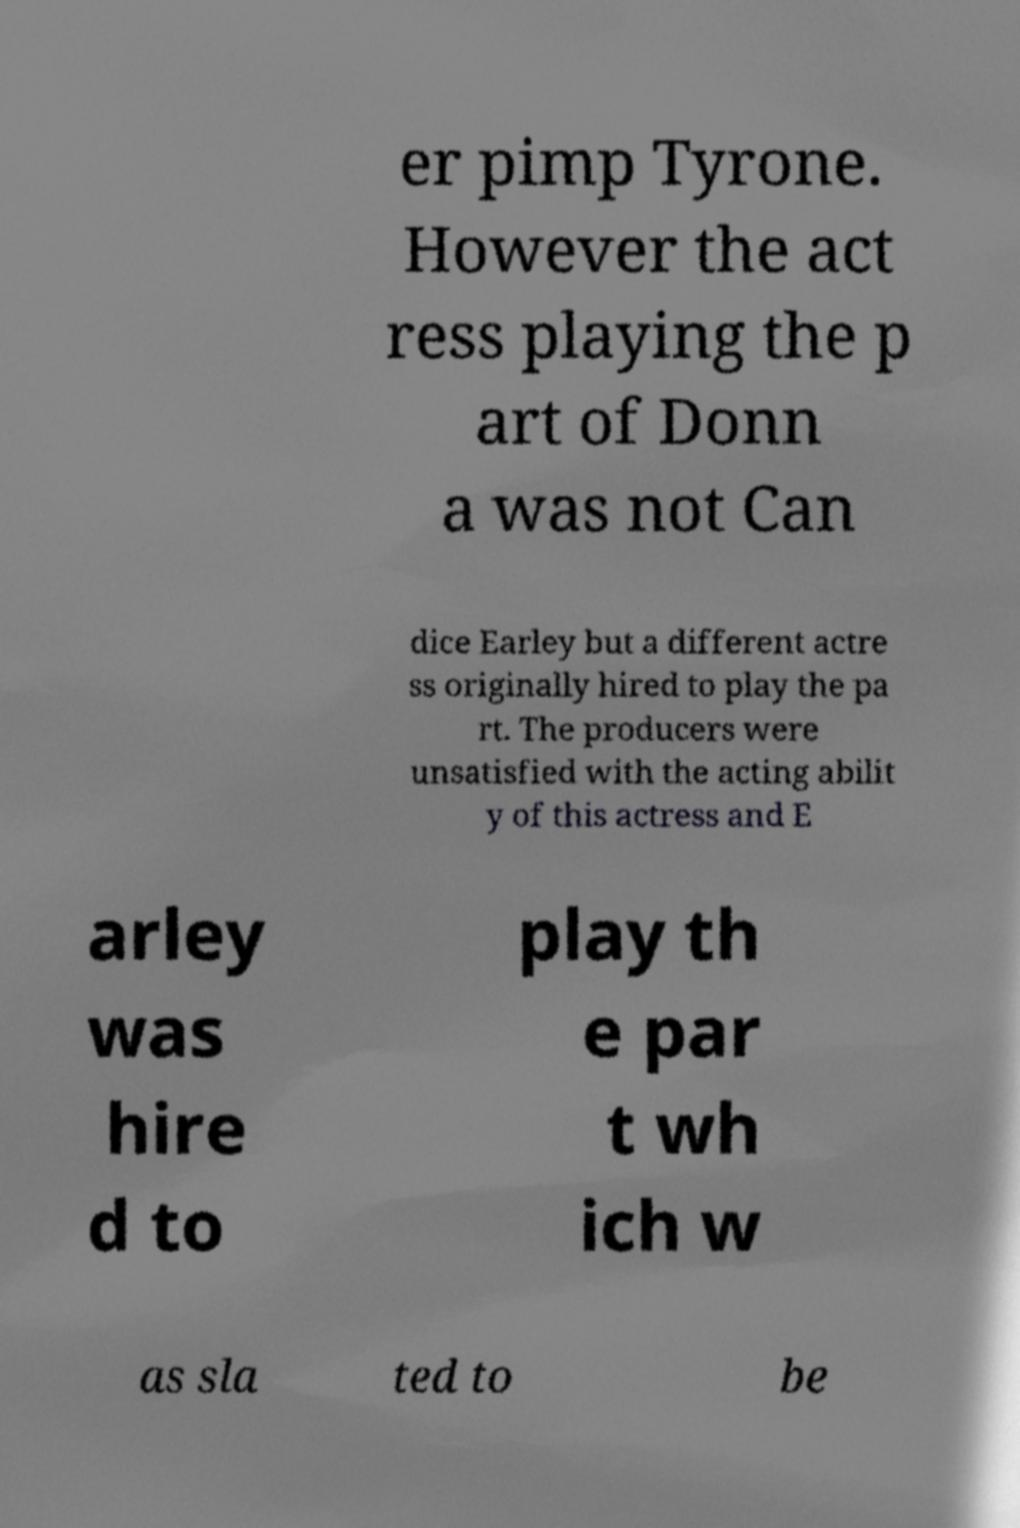There's text embedded in this image that I need extracted. Can you transcribe it verbatim? er pimp Tyrone. However the act ress playing the p art of Donn a was not Can dice Earley but a different actre ss originally hired to play the pa rt. The producers were unsatisfied with the acting abilit y of this actress and E arley was hire d to play th e par t wh ich w as sla ted to be 